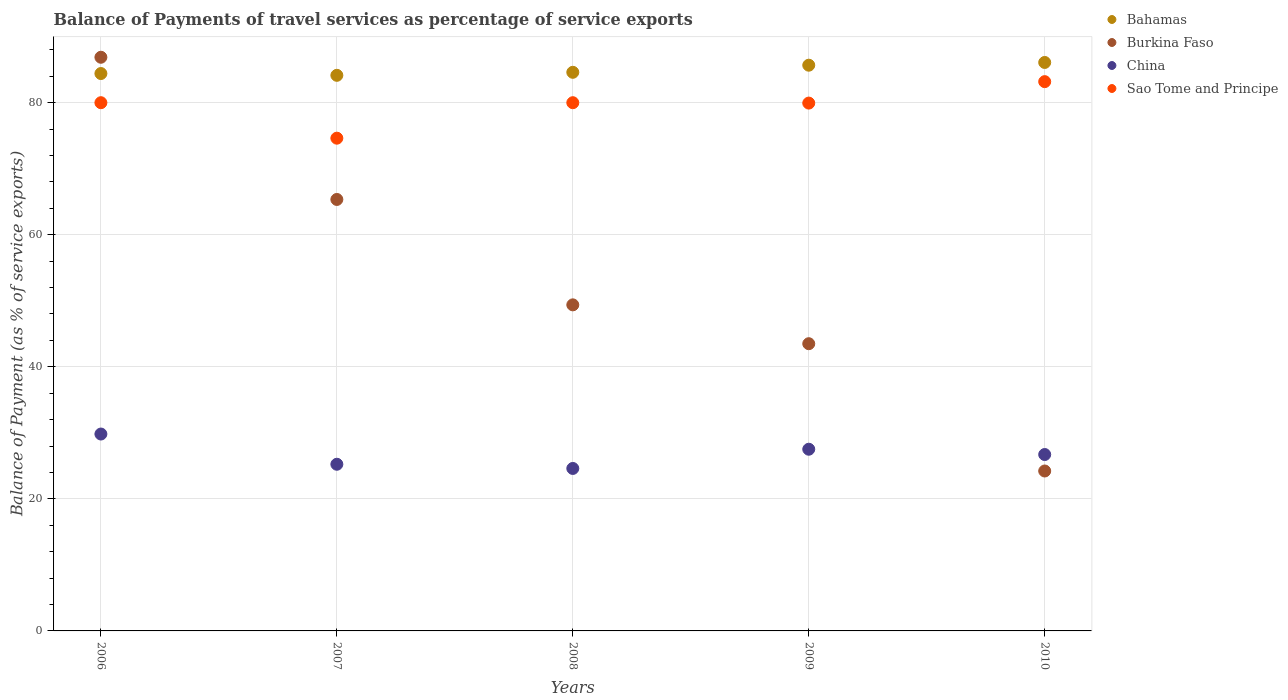Is the number of dotlines equal to the number of legend labels?
Keep it short and to the point. Yes. What is the balance of payments of travel services in Bahamas in 2009?
Your response must be concise. 85.68. Across all years, what is the maximum balance of payments of travel services in Bahamas?
Give a very brief answer. 86.09. Across all years, what is the minimum balance of payments of travel services in Bahamas?
Keep it short and to the point. 84.14. In which year was the balance of payments of travel services in China maximum?
Provide a succinct answer. 2006. What is the total balance of payments of travel services in Sao Tome and Principe in the graph?
Offer a very short reply. 397.75. What is the difference between the balance of payments of travel services in China in 2006 and that in 2008?
Provide a short and direct response. 5.21. What is the difference between the balance of payments of travel services in Sao Tome and Principe in 2008 and the balance of payments of travel services in Bahamas in 2007?
Make the answer very short. -4.15. What is the average balance of payments of travel services in Bahamas per year?
Ensure brevity in your answer.  84.99. In the year 2008, what is the difference between the balance of payments of travel services in China and balance of payments of travel services in Sao Tome and Principe?
Provide a succinct answer. -55.39. What is the ratio of the balance of payments of travel services in Sao Tome and Principe in 2007 to that in 2009?
Offer a terse response. 0.93. What is the difference between the highest and the second highest balance of payments of travel services in Sao Tome and Principe?
Give a very brief answer. 3.19. What is the difference between the highest and the lowest balance of payments of travel services in Bahamas?
Provide a succinct answer. 1.95. Is it the case that in every year, the sum of the balance of payments of travel services in Sao Tome and Principe and balance of payments of travel services in China  is greater than the balance of payments of travel services in Bahamas?
Provide a short and direct response. Yes. Does the balance of payments of travel services in Bahamas monotonically increase over the years?
Your response must be concise. No. Is the balance of payments of travel services in Burkina Faso strictly less than the balance of payments of travel services in Bahamas over the years?
Make the answer very short. No. How many dotlines are there?
Your response must be concise. 4. How many years are there in the graph?
Offer a terse response. 5. What is the difference between two consecutive major ticks on the Y-axis?
Your answer should be compact. 20. Does the graph contain any zero values?
Offer a terse response. No. Where does the legend appear in the graph?
Ensure brevity in your answer.  Top right. How many legend labels are there?
Make the answer very short. 4. What is the title of the graph?
Keep it short and to the point. Balance of Payments of travel services as percentage of service exports. What is the label or title of the X-axis?
Provide a succinct answer. Years. What is the label or title of the Y-axis?
Offer a very short reply. Balance of Payment (as % of service exports). What is the Balance of Payment (as % of service exports) of Bahamas in 2006?
Provide a succinct answer. 84.42. What is the Balance of Payment (as % of service exports) of Burkina Faso in 2006?
Offer a very short reply. 86.88. What is the Balance of Payment (as % of service exports) in China in 2006?
Provide a succinct answer. 29.82. What is the Balance of Payment (as % of service exports) in Sao Tome and Principe in 2006?
Your answer should be compact. 80. What is the Balance of Payment (as % of service exports) in Bahamas in 2007?
Your answer should be compact. 84.14. What is the Balance of Payment (as % of service exports) in Burkina Faso in 2007?
Your response must be concise. 65.35. What is the Balance of Payment (as % of service exports) in China in 2007?
Provide a short and direct response. 25.24. What is the Balance of Payment (as % of service exports) of Sao Tome and Principe in 2007?
Your response must be concise. 74.62. What is the Balance of Payment (as % of service exports) in Bahamas in 2008?
Your answer should be compact. 84.6. What is the Balance of Payment (as % of service exports) of Burkina Faso in 2008?
Give a very brief answer. 49.38. What is the Balance of Payment (as % of service exports) in China in 2008?
Give a very brief answer. 24.61. What is the Balance of Payment (as % of service exports) of Sao Tome and Principe in 2008?
Your response must be concise. 80. What is the Balance of Payment (as % of service exports) of Bahamas in 2009?
Ensure brevity in your answer.  85.68. What is the Balance of Payment (as % of service exports) in Burkina Faso in 2009?
Your response must be concise. 43.5. What is the Balance of Payment (as % of service exports) of China in 2009?
Provide a short and direct response. 27.52. What is the Balance of Payment (as % of service exports) in Sao Tome and Principe in 2009?
Make the answer very short. 79.94. What is the Balance of Payment (as % of service exports) in Bahamas in 2010?
Ensure brevity in your answer.  86.09. What is the Balance of Payment (as % of service exports) of Burkina Faso in 2010?
Your response must be concise. 24.22. What is the Balance of Payment (as % of service exports) in China in 2010?
Your answer should be very brief. 26.72. What is the Balance of Payment (as % of service exports) of Sao Tome and Principe in 2010?
Provide a succinct answer. 83.19. Across all years, what is the maximum Balance of Payment (as % of service exports) in Bahamas?
Make the answer very short. 86.09. Across all years, what is the maximum Balance of Payment (as % of service exports) of Burkina Faso?
Ensure brevity in your answer.  86.88. Across all years, what is the maximum Balance of Payment (as % of service exports) of China?
Your answer should be very brief. 29.82. Across all years, what is the maximum Balance of Payment (as % of service exports) of Sao Tome and Principe?
Give a very brief answer. 83.19. Across all years, what is the minimum Balance of Payment (as % of service exports) in Bahamas?
Your answer should be very brief. 84.14. Across all years, what is the minimum Balance of Payment (as % of service exports) in Burkina Faso?
Keep it short and to the point. 24.22. Across all years, what is the minimum Balance of Payment (as % of service exports) in China?
Give a very brief answer. 24.61. Across all years, what is the minimum Balance of Payment (as % of service exports) in Sao Tome and Principe?
Make the answer very short. 74.62. What is the total Balance of Payment (as % of service exports) of Bahamas in the graph?
Ensure brevity in your answer.  424.93. What is the total Balance of Payment (as % of service exports) in Burkina Faso in the graph?
Offer a very short reply. 269.33. What is the total Balance of Payment (as % of service exports) of China in the graph?
Ensure brevity in your answer.  133.9. What is the total Balance of Payment (as % of service exports) in Sao Tome and Principe in the graph?
Offer a very short reply. 397.75. What is the difference between the Balance of Payment (as % of service exports) of Bahamas in 2006 and that in 2007?
Your answer should be compact. 0.27. What is the difference between the Balance of Payment (as % of service exports) of Burkina Faso in 2006 and that in 2007?
Keep it short and to the point. 21.53. What is the difference between the Balance of Payment (as % of service exports) of China in 2006 and that in 2007?
Provide a short and direct response. 4.58. What is the difference between the Balance of Payment (as % of service exports) in Sao Tome and Principe in 2006 and that in 2007?
Provide a succinct answer. 5.37. What is the difference between the Balance of Payment (as % of service exports) in Bahamas in 2006 and that in 2008?
Ensure brevity in your answer.  -0.19. What is the difference between the Balance of Payment (as % of service exports) of Burkina Faso in 2006 and that in 2008?
Ensure brevity in your answer.  37.5. What is the difference between the Balance of Payment (as % of service exports) of China in 2006 and that in 2008?
Your answer should be compact. 5.21. What is the difference between the Balance of Payment (as % of service exports) of Bahamas in 2006 and that in 2009?
Keep it short and to the point. -1.26. What is the difference between the Balance of Payment (as % of service exports) of Burkina Faso in 2006 and that in 2009?
Provide a succinct answer. 43.38. What is the difference between the Balance of Payment (as % of service exports) of China in 2006 and that in 2009?
Keep it short and to the point. 2.3. What is the difference between the Balance of Payment (as % of service exports) of Sao Tome and Principe in 2006 and that in 2009?
Your response must be concise. 0.06. What is the difference between the Balance of Payment (as % of service exports) of Bahamas in 2006 and that in 2010?
Your answer should be very brief. -1.68. What is the difference between the Balance of Payment (as % of service exports) of Burkina Faso in 2006 and that in 2010?
Keep it short and to the point. 62.66. What is the difference between the Balance of Payment (as % of service exports) of China in 2006 and that in 2010?
Your response must be concise. 3.1. What is the difference between the Balance of Payment (as % of service exports) in Sao Tome and Principe in 2006 and that in 2010?
Your response must be concise. -3.19. What is the difference between the Balance of Payment (as % of service exports) in Bahamas in 2007 and that in 2008?
Make the answer very short. -0.46. What is the difference between the Balance of Payment (as % of service exports) in Burkina Faso in 2007 and that in 2008?
Your response must be concise. 15.96. What is the difference between the Balance of Payment (as % of service exports) in China in 2007 and that in 2008?
Provide a succinct answer. 0.64. What is the difference between the Balance of Payment (as % of service exports) of Sao Tome and Principe in 2007 and that in 2008?
Provide a short and direct response. -5.37. What is the difference between the Balance of Payment (as % of service exports) in Bahamas in 2007 and that in 2009?
Your answer should be compact. -1.53. What is the difference between the Balance of Payment (as % of service exports) in Burkina Faso in 2007 and that in 2009?
Provide a succinct answer. 21.85. What is the difference between the Balance of Payment (as % of service exports) in China in 2007 and that in 2009?
Provide a succinct answer. -2.28. What is the difference between the Balance of Payment (as % of service exports) of Sao Tome and Principe in 2007 and that in 2009?
Make the answer very short. -5.31. What is the difference between the Balance of Payment (as % of service exports) of Bahamas in 2007 and that in 2010?
Ensure brevity in your answer.  -1.95. What is the difference between the Balance of Payment (as % of service exports) of Burkina Faso in 2007 and that in 2010?
Your response must be concise. 41.12. What is the difference between the Balance of Payment (as % of service exports) of China in 2007 and that in 2010?
Your answer should be very brief. -1.47. What is the difference between the Balance of Payment (as % of service exports) in Sao Tome and Principe in 2007 and that in 2010?
Ensure brevity in your answer.  -8.56. What is the difference between the Balance of Payment (as % of service exports) in Bahamas in 2008 and that in 2009?
Your response must be concise. -1.08. What is the difference between the Balance of Payment (as % of service exports) of Burkina Faso in 2008 and that in 2009?
Your answer should be compact. 5.88. What is the difference between the Balance of Payment (as % of service exports) of China in 2008 and that in 2009?
Your response must be concise. -2.91. What is the difference between the Balance of Payment (as % of service exports) in Sao Tome and Principe in 2008 and that in 2009?
Keep it short and to the point. 0.06. What is the difference between the Balance of Payment (as % of service exports) in Bahamas in 2008 and that in 2010?
Your answer should be compact. -1.49. What is the difference between the Balance of Payment (as % of service exports) in Burkina Faso in 2008 and that in 2010?
Give a very brief answer. 25.16. What is the difference between the Balance of Payment (as % of service exports) in China in 2008 and that in 2010?
Offer a terse response. -2.11. What is the difference between the Balance of Payment (as % of service exports) in Sao Tome and Principe in 2008 and that in 2010?
Provide a succinct answer. -3.19. What is the difference between the Balance of Payment (as % of service exports) of Bahamas in 2009 and that in 2010?
Ensure brevity in your answer.  -0.42. What is the difference between the Balance of Payment (as % of service exports) of Burkina Faso in 2009 and that in 2010?
Your response must be concise. 19.28. What is the difference between the Balance of Payment (as % of service exports) of China in 2009 and that in 2010?
Offer a terse response. 0.8. What is the difference between the Balance of Payment (as % of service exports) of Sao Tome and Principe in 2009 and that in 2010?
Offer a very short reply. -3.25. What is the difference between the Balance of Payment (as % of service exports) in Bahamas in 2006 and the Balance of Payment (as % of service exports) in Burkina Faso in 2007?
Your answer should be compact. 19.07. What is the difference between the Balance of Payment (as % of service exports) of Bahamas in 2006 and the Balance of Payment (as % of service exports) of China in 2007?
Your answer should be very brief. 59.17. What is the difference between the Balance of Payment (as % of service exports) in Bahamas in 2006 and the Balance of Payment (as % of service exports) in Sao Tome and Principe in 2007?
Ensure brevity in your answer.  9.79. What is the difference between the Balance of Payment (as % of service exports) of Burkina Faso in 2006 and the Balance of Payment (as % of service exports) of China in 2007?
Make the answer very short. 61.64. What is the difference between the Balance of Payment (as % of service exports) of Burkina Faso in 2006 and the Balance of Payment (as % of service exports) of Sao Tome and Principe in 2007?
Ensure brevity in your answer.  12.26. What is the difference between the Balance of Payment (as % of service exports) of China in 2006 and the Balance of Payment (as % of service exports) of Sao Tome and Principe in 2007?
Offer a very short reply. -44.81. What is the difference between the Balance of Payment (as % of service exports) in Bahamas in 2006 and the Balance of Payment (as % of service exports) in Burkina Faso in 2008?
Keep it short and to the point. 35.03. What is the difference between the Balance of Payment (as % of service exports) in Bahamas in 2006 and the Balance of Payment (as % of service exports) in China in 2008?
Ensure brevity in your answer.  59.81. What is the difference between the Balance of Payment (as % of service exports) in Bahamas in 2006 and the Balance of Payment (as % of service exports) in Sao Tome and Principe in 2008?
Give a very brief answer. 4.42. What is the difference between the Balance of Payment (as % of service exports) of Burkina Faso in 2006 and the Balance of Payment (as % of service exports) of China in 2008?
Ensure brevity in your answer.  62.27. What is the difference between the Balance of Payment (as % of service exports) of Burkina Faso in 2006 and the Balance of Payment (as % of service exports) of Sao Tome and Principe in 2008?
Provide a short and direct response. 6.88. What is the difference between the Balance of Payment (as % of service exports) of China in 2006 and the Balance of Payment (as % of service exports) of Sao Tome and Principe in 2008?
Make the answer very short. -50.18. What is the difference between the Balance of Payment (as % of service exports) of Bahamas in 2006 and the Balance of Payment (as % of service exports) of Burkina Faso in 2009?
Provide a succinct answer. 40.92. What is the difference between the Balance of Payment (as % of service exports) in Bahamas in 2006 and the Balance of Payment (as % of service exports) in China in 2009?
Your answer should be compact. 56.9. What is the difference between the Balance of Payment (as % of service exports) in Bahamas in 2006 and the Balance of Payment (as % of service exports) in Sao Tome and Principe in 2009?
Your answer should be very brief. 4.48. What is the difference between the Balance of Payment (as % of service exports) of Burkina Faso in 2006 and the Balance of Payment (as % of service exports) of China in 2009?
Give a very brief answer. 59.36. What is the difference between the Balance of Payment (as % of service exports) in Burkina Faso in 2006 and the Balance of Payment (as % of service exports) in Sao Tome and Principe in 2009?
Offer a terse response. 6.94. What is the difference between the Balance of Payment (as % of service exports) in China in 2006 and the Balance of Payment (as % of service exports) in Sao Tome and Principe in 2009?
Offer a terse response. -50.12. What is the difference between the Balance of Payment (as % of service exports) in Bahamas in 2006 and the Balance of Payment (as % of service exports) in Burkina Faso in 2010?
Make the answer very short. 60.19. What is the difference between the Balance of Payment (as % of service exports) in Bahamas in 2006 and the Balance of Payment (as % of service exports) in China in 2010?
Ensure brevity in your answer.  57.7. What is the difference between the Balance of Payment (as % of service exports) in Bahamas in 2006 and the Balance of Payment (as % of service exports) in Sao Tome and Principe in 2010?
Your answer should be compact. 1.23. What is the difference between the Balance of Payment (as % of service exports) in Burkina Faso in 2006 and the Balance of Payment (as % of service exports) in China in 2010?
Give a very brief answer. 60.16. What is the difference between the Balance of Payment (as % of service exports) in Burkina Faso in 2006 and the Balance of Payment (as % of service exports) in Sao Tome and Principe in 2010?
Provide a succinct answer. 3.69. What is the difference between the Balance of Payment (as % of service exports) in China in 2006 and the Balance of Payment (as % of service exports) in Sao Tome and Principe in 2010?
Your response must be concise. -53.37. What is the difference between the Balance of Payment (as % of service exports) of Bahamas in 2007 and the Balance of Payment (as % of service exports) of Burkina Faso in 2008?
Your answer should be compact. 34.76. What is the difference between the Balance of Payment (as % of service exports) of Bahamas in 2007 and the Balance of Payment (as % of service exports) of China in 2008?
Give a very brief answer. 59.54. What is the difference between the Balance of Payment (as % of service exports) of Bahamas in 2007 and the Balance of Payment (as % of service exports) of Sao Tome and Principe in 2008?
Keep it short and to the point. 4.15. What is the difference between the Balance of Payment (as % of service exports) of Burkina Faso in 2007 and the Balance of Payment (as % of service exports) of China in 2008?
Provide a succinct answer. 40.74. What is the difference between the Balance of Payment (as % of service exports) in Burkina Faso in 2007 and the Balance of Payment (as % of service exports) in Sao Tome and Principe in 2008?
Offer a very short reply. -14.65. What is the difference between the Balance of Payment (as % of service exports) of China in 2007 and the Balance of Payment (as % of service exports) of Sao Tome and Principe in 2008?
Keep it short and to the point. -54.76. What is the difference between the Balance of Payment (as % of service exports) of Bahamas in 2007 and the Balance of Payment (as % of service exports) of Burkina Faso in 2009?
Your response must be concise. 40.65. What is the difference between the Balance of Payment (as % of service exports) of Bahamas in 2007 and the Balance of Payment (as % of service exports) of China in 2009?
Your answer should be very brief. 56.63. What is the difference between the Balance of Payment (as % of service exports) of Bahamas in 2007 and the Balance of Payment (as % of service exports) of Sao Tome and Principe in 2009?
Keep it short and to the point. 4.21. What is the difference between the Balance of Payment (as % of service exports) of Burkina Faso in 2007 and the Balance of Payment (as % of service exports) of China in 2009?
Provide a short and direct response. 37.83. What is the difference between the Balance of Payment (as % of service exports) in Burkina Faso in 2007 and the Balance of Payment (as % of service exports) in Sao Tome and Principe in 2009?
Offer a terse response. -14.59. What is the difference between the Balance of Payment (as % of service exports) in China in 2007 and the Balance of Payment (as % of service exports) in Sao Tome and Principe in 2009?
Keep it short and to the point. -54.7. What is the difference between the Balance of Payment (as % of service exports) in Bahamas in 2007 and the Balance of Payment (as % of service exports) in Burkina Faso in 2010?
Give a very brief answer. 59.92. What is the difference between the Balance of Payment (as % of service exports) of Bahamas in 2007 and the Balance of Payment (as % of service exports) of China in 2010?
Your response must be concise. 57.43. What is the difference between the Balance of Payment (as % of service exports) of Bahamas in 2007 and the Balance of Payment (as % of service exports) of Sao Tome and Principe in 2010?
Keep it short and to the point. 0.96. What is the difference between the Balance of Payment (as % of service exports) in Burkina Faso in 2007 and the Balance of Payment (as % of service exports) in China in 2010?
Provide a short and direct response. 38.63. What is the difference between the Balance of Payment (as % of service exports) in Burkina Faso in 2007 and the Balance of Payment (as % of service exports) in Sao Tome and Principe in 2010?
Give a very brief answer. -17.84. What is the difference between the Balance of Payment (as % of service exports) in China in 2007 and the Balance of Payment (as % of service exports) in Sao Tome and Principe in 2010?
Give a very brief answer. -57.95. What is the difference between the Balance of Payment (as % of service exports) of Bahamas in 2008 and the Balance of Payment (as % of service exports) of Burkina Faso in 2009?
Offer a terse response. 41.1. What is the difference between the Balance of Payment (as % of service exports) of Bahamas in 2008 and the Balance of Payment (as % of service exports) of China in 2009?
Offer a terse response. 57.09. What is the difference between the Balance of Payment (as % of service exports) of Bahamas in 2008 and the Balance of Payment (as % of service exports) of Sao Tome and Principe in 2009?
Keep it short and to the point. 4.66. What is the difference between the Balance of Payment (as % of service exports) of Burkina Faso in 2008 and the Balance of Payment (as % of service exports) of China in 2009?
Keep it short and to the point. 21.87. What is the difference between the Balance of Payment (as % of service exports) of Burkina Faso in 2008 and the Balance of Payment (as % of service exports) of Sao Tome and Principe in 2009?
Make the answer very short. -30.56. What is the difference between the Balance of Payment (as % of service exports) of China in 2008 and the Balance of Payment (as % of service exports) of Sao Tome and Principe in 2009?
Provide a succinct answer. -55.33. What is the difference between the Balance of Payment (as % of service exports) of Bahamas in 2008 and the Balance of Payment (as % of service exports) of Burkina Faso in 2010?
Keep it short and to the point. 60.38. What is the difference between the Balance of Payment (as % of service exports) in Bahamas in 2008 and the Balance of Payment (as % of service exports) in China in 2010?
Ensure brevity in your answer.  57.89. What is the difference between the Balance of Payment (as % of service exports) in Bahamas in 2008 and the Balance of Payment (as % of service exports) in Sao Tome and Principe in 2010?
Your answer should be very brief. 1.41. What is the difference between the Balance of Payment (as % of service exports) of Burkina Faso in 2008 and the Balance of Payment (as % of service exports) of China in 2010?
Your answer should be compact. 22.67. What is the difference between the Balance of Payment (as % of service exports) of Burkina Faso in 2008 and the Balance of Payment (as % of service exports) of Sao Tome and Principe in 2010?
Ensure brevity in your answer.  -33.81. What is the difference between the Balance of Payment (as % of service exports) of China in 2008 and the Balance of Payment (as % of service exports) of Sao Tome and Principe in 2010?
Ensure brevity in your answer.  -58.58. What is the difference between the Balance of Payment (as % of service exports) of Bahamas in 2009 and the Balance of Payment (as % of service exports) of Burkina Faso in 2010?
Your response must be concise. 61.46. What is the difference between the Balance of Payment (as % of service exports) in Bahamas in 2009 and the Balance of Payment (as % of service exports) in China in 2010?
Keep it short and to the point. 58.96. What is the difference between the Balance of Payment (as % of service exports) in Bahamas in 2009 and the Balance of Payment (as % of service exports) in Sao Tome and Principe in 2010?
Give a very brief answer. 2.49. What is the difference between the Balance of Payment (as % of service exports) of Burkina Faso in 2009 and the Balance of Payment (as % of service exports) of China in 2010?
Offer a very short reply. 16.78. What is the difference between the Balance of Payment (as % of service exports) in Burkina Faso in 2009 and the Balance of Payment (as % of service exports) in Sao Tome and Principe in 2010?
Your answer should be compact. -39.69. What is the difference between the Balance of Payment (as % of service exports) of China in 2009 and the Balance of Payment (as % of service exports) of Sao Tome and Principe in 2010?
Offer a very short reply. -55.67. What is the average Balance of Payment (as % of service exports) of Bahamas per year?
Keep it short and to the point. 84.99. What is the average Balance of Payment (as % of service exports) of Burkina Faso per year?
Provide a short and direct response. 53.87. What is the average Balance of Payment (as % of service exports) of China per year?
Make the answer very short. 26.78. What is the average Balance of Payment (as % of service exports) in Sao Tome and Principe per year?
Your answer should be compact. 79.55. In the year 2006, what is the difference between the Balance of Payment (as % of service exports) of Bahamas and Balance of Payment (as % of service exports) of Burkina Faso?
Offer a terse response. -2.46. In the year 2006, what is the difference between the Balance of Payment (as % of service exports) of Bahamas and Balance of Payment (as % of service exports) of China?
Make the answer very short. 54.6. In the year 2006, what is the difference between the Balance of Payment (as % of service exports) in Bahamas and Balance of Payment (as % of service exports) in Sao Tome and Principe?
Your response must be concise. 4.42. In the year 2006, what is the difference between the Balance of Payment (as % of service exports) of Burkina Faso and Balance of Payment (as % of service exports) of China?
Your answer should be very brief. 57.06. In the year 2006, what is the difference between the Balance of Payment (as % of service exports) of Burkina Faso and Balance of Payment (as % of service exports) of Sao Tome and Principe?
Ensure brevity in your answer.  6.88. In the year 2006, what is the difference between the Balance of Payment (as % of service exports) in China and Balance of Payment (as % of service exports) in Sao Tome and Principe?
Provide a short and direct response. -50.18. In the year 2007, what is the difference between the Balance of Payment (as % of service exports) of Bahamas and Balance of Payment (as % of service exports) of Burkina Faso?
Ensure brevity in your answer.  18.8. In the year 2007, what is the difference between the Balance of Payment (as % of service exports) of Bahamas and Balance of Payment (as % of service exports) of China?
Offer a terse response. 58.9. In the year 2007, what is the difference between the Balance of Payment (as % of service exports) of Bahamas and Balance of Payment (as % of service exports) of Sao Tome and Principe?
Provide a short and direct response. 9.52. In the year 2007, what is the difference between the Balance of Payment (as % of service exports) in Burkina Faso and Balance of Payment (as % of service exports) in China?
Keep it short and to the point. 40.1. In the year 2007, what is the difference between the Balance of Payment (as % of service exports) of Burkina Faso and Balance of Payment (as % of service exports) of Sao Tome and Principe?
Your response must be concise. -9.28. In the year 2007, what is the difference between the Balance of Payment (as % of service exports) in China and Balance of Payment (as % of service exports) in Sao Tome and Principe?
Your answer should be very brief. -49.38. In the year 2008, what is the difference between the Balance of Payment (as % of service exports) of Bahamas and Balance of Payment (as % of service exports) of Burkina Faso?
Offer a very short reply. 35.22. In the year 2008, what is the difference between the Balance of Payment (as % of service exports) in Bahamas and Balance of Payment (as % of service exports) in China?
Make the answer very short. 60. In the year 2008, what is the difference between the Balance of Payment (as % of service exports) in Bahamas and Balance of Payment (as % of service exports) in Sao Tome and Principe?
Your response must be concise. 4.6. In the year 2008, what is the difference between the Balance of Payment (as % of service exports) in Burkina Faso and Balance of Payment (as % of service exports) in China?
Provide a short and direct response. 24.78. In the year 2008, what is the difference between the Balance of Payment (as % of service exports) in Burkina Faso and Balance of Payment (as % of service exports) in Sao Tome and Principe?
Your answer should be compact. -30.62. In the year 2008, what is the difference between the Balance of Payment (as % of service exports) of China and Balance of Payment (as % of service exports) of Sao Tome and Principe?
Ensure brevity in your answer.  -55.39. In the year 2009, what is the difference between the Balance of Payment (as % of service exports) of Bahamas and Balance of Payment (as % of service exports) of Burkina Faso?
Your answer should be compact. 42.18. In the year 2009, what is the difference between the Balance of Payment (as % of service exports) in Bahamas and Balance of Payment (as % of service exports) in China?
Your answer should be very brief. 58.16. In the year 2009, what is the difference between the Balance of Payment (as % of service exports) of Bahamas and Balance of Payment (as % of service exports) of Sao Tome and Principe?
Offer a terse response. 5.74. In the year 2009, what is the difference between the Balance of Payment (as % of service exports) of Burkina Faso and Balance of Payment (as % of service exports) of China?
Provide a succinct answer. 15.98. In the year 2009, what is the difference between the Balance of Payment (as % of service exports) in Burkina Faso and Balance of Payment (as % of service exports) in Sao Tome and Principe?
Your response must be concise. -36.44. In the year 2009, what is the difference between the Balance of Payment (as % of service exports) of China and Balance of Payment (as % of service exports) of Sao Tome and Principe?
Give a very brief answer. -52.42. In the year 2010, what is the difference between the Balance of Payment (as % of service exports) in Bahamas and Balance of Payment (as % of service exports) in Burkina Faso?
Ensure brevity in your answer.  61.87. In the year 2010, what is the difference between the Balance of Payment (as % of service exports) of Bahamas and Balance of Payment (as % of service exports) of China?
Provide a succinct answer. 59.38. In the year 2010, what is the difference between the Balance of Payment (as % of service exports) in Bahamas and Balance of Payment (as % of service exports) in Sao Tome and Principe?
Provide a short and direct response. 2.9. In the year 2010, what is the difference between the Balance of Payment (as % of service exports) in Burkina Faso and Balance of Payment (as % of service exports) in China?
Offer a terse response. -2.49. In the year 2010, what is the difference between the Balance of Payment (as % of service exports) in Burkina Faso and Balance of Payment (as % of service exports) in Sao Tome and Principe?
Provide a short and direct response. -58.97. In the year 2010, what is the difference between the Balance of Payment (as % of service exports) in China and Balance of Payment (as % of service exports) in Sao Tome and Principe?
Your response must be concise. -56.47. What is the ratio of the Balance of Payment (as % of service exports) in Bahamas in 2006 to that in 2007?
Offer a very short reply. 1. What is the ratio of the Balance of Payment (as % of service exports) of Burkina Faso in 2006 to that in 2007?
Offer a very short reply. 1.33. What is the ratio of the Balance of Payment (as % of service exports) of China in 2006 to that in 2007?
Your answer should be compact. 1.18. What is the ratio of the Balance of Payment (as % of service exports) in Sao Tome and Principe in 2006 to that in 2007?
Make the answer very short. 1.07. What is the ratio of the Balance of Payment (as % of service exports) in Bahamas in 2006 to that in 2008?
Your response must be concise. 1. What is the ratio of the Balance of Payment (as % of service exports) in Burkina Faso in 2006 to that in 2008?
Make the answer very short. 1.76. What is the ratio of the Balance of Payment (as % of service exports) of China in 2006 to that in 2008?
Your answer should be compact. 1.21. What is the ratio of the Balance of Payment (as % of service exports) in Sao Tome and Principe in 2006 to that in 2008?
Keep it short and to the point. 1. What is the ratio of the Balance of Payment (as % of service exports) in Bahamas in 2006 to that in 2009?
Ensure brevity in your answer.  0.99. What is the ratio of the Balance of Payment (as % of service exports) in Burkina Faso in 2006 to that in 2009?
Provide a succinct answer. 2. What is the ratio of the Balance of Payment (as % of service exports) of China in 2006 to that in 2009?
Keep it short and to the point. 1.08. What is the ratio of the Balance of Payment (as % of service exports) in Sao Tome and Principe in 2006 to that in 2009?
Keep it short and to the point. 1. What is the ratio of the Balance of Payment (as % of service exports) of Bahamas in 2006 to that in 2010?
Offer a very short reply. 0.98. What is the ratio of the Balance of Payment (as % of service exports) of Burkina Faso in 2006 to that in 2010?
Provide a succinct answer. 3.59. What is the ratio of the Balance of Payment (as % of service exports) in China in 2006 to that in 2010?
Provide a short and direct response. 1.12. What is the ratio of the Balance of Payment (as % of service exports) in Sao Tome and Principe in 2006 to that in 2010?
Make the answer very short. 0.96. What is the ratio of the Balance of Payment (as % of service exports) of Burkina Faso in 2007 to that in 2008?
Offer a terse response. 1.32. What is the ratio of the Balance of Payment (as % of service exports) in China in 2007 to that in 2008?
Your answer should be very brief. 1.03. What is the ratio of the Balance of Payment (as % of service exports) of Sao Tome and Principe in 2007 to that in 2008?
Offer a very short reply. 0.93. What is the ratio of the Balance of Payment (as % of service exports) in Bahamas in 2007 to that in 2009?
Give a very brief answer. 0.98. What is the ratio of the Balance of Payment (as % of service exports) of Burkina Faso in 2007 to that in 2009?
Give a very brief answer. 1.5. What is the ratio of the Balance of Payment (as % of service exports) in China in 2007 to that in 2009?
Your answer should be very brief. 0.92. What is the ratio of the Balance of Payment (as % of service exports) in Sao Tome and Principe in 2007 to that in 2009?
Keep it short and to the point. 0.93. What is the ratio of the Balance of Payment (as % of service exports) of Bahamas in 2007 to that in 2010?
Your answer should be very brief. 0.98. What is the ratio of the Balance of Payment (as % of service exports) of Burkina Faso in 2007 to that in 2010?
Keep it short and to the point. 2.7. What is the ratio of the Balance of Payment (as % of service exports) of China in 2007 to that in 2010?
Your answer should be compact. 0.94. What is the ratio of the Balance of Payment (as % of service exports) of Sao Tome and Principe in 2007 to that in 2010?
Give a very brief answer. 0.9. What is the ratio of the Balance of Payment (as % of service exports) in Bahamas in 2008 to that in 2009?
Keep it short and to the point. 0.99. What is the ratio of the Balance of Payment (as % of service exports) in Burkina Faso in 2008 to that in 2009?
Make the answer very short. 1.14. What is the ratio of the Balance of Payment (as % of service exports) of China in 2008 to that in 2009?
Provide a short and direct response. 0.89. What is the ratio of the Balance of Payment (as % of service exports) in Bahamas in 2008 to that in 2010?
Provide a succinct answer. 0.98. What is the ratio of the Balance of Payment (as % of service exports) of Burkina Faso in 2008 to that in 2010?
Offer a very short reply. 2.04. What is the ratio of the Balance of Payment (as % of service exports) of China in 2008 to that in 2010?
Ensure brevity in your answer.  0.92. What is the ratio of the Balance of Payment (as % of service exports) of Sao Tome and Principe in 2008 to that in 2010?
Make the answer very short. 0.96. What is the ratio of the Balance of Payment (as % of service exports) in Bahamas in 2009 to that in 2010?
Give a very brief answer. 1. What is the ratio of the Balance of Payment (as % of service exports) of Burkina Faso in 2009 to that in 2010?
Your answer should be very brief. 1.8. What is the ratio of the Balance of Payment (as % of service exports) in China in 2009 to that in 2010?
Ensure brevity in your answer.  1.03. What is the difference between the highest and the second highest Balance of Payment (as % of service exports) in Bahamas?
Make the answer very short. 0.42. What is the difference between the highest and the second highest Balance of Payment (as % of service exports) of Burkina Faso?
Offer a very short reply. 21.53. What is the difference between the highest and the second highest Balance of Payment (as % of service exports) of China?
Provide a succinct answer. 2.3. What is the difference between the highest and the second highest Balance of Payment (as % of service exports) in Sao Tome and Principe?
Provide a succinct answer. 3.19. What is the difference between the highest and the lowest Balance of Payment (as % of service exports) in Bahamas?
Your answer should be very brief. 1.95. What is the difference between the highest and the lowest Balance of Payment (as % of service exports) of Burkina Faso?
Your response must be concise. 62.66. What is the difference between the highest and the lowest Balance of Payment (as % of service exports) of China?
Offer a very short reply. 5.21. What is the difference between the highest and the lowest Balance of Payment (as % of service exports) of Sao Tome and Principe?
Make the answer very short. 8.56. 